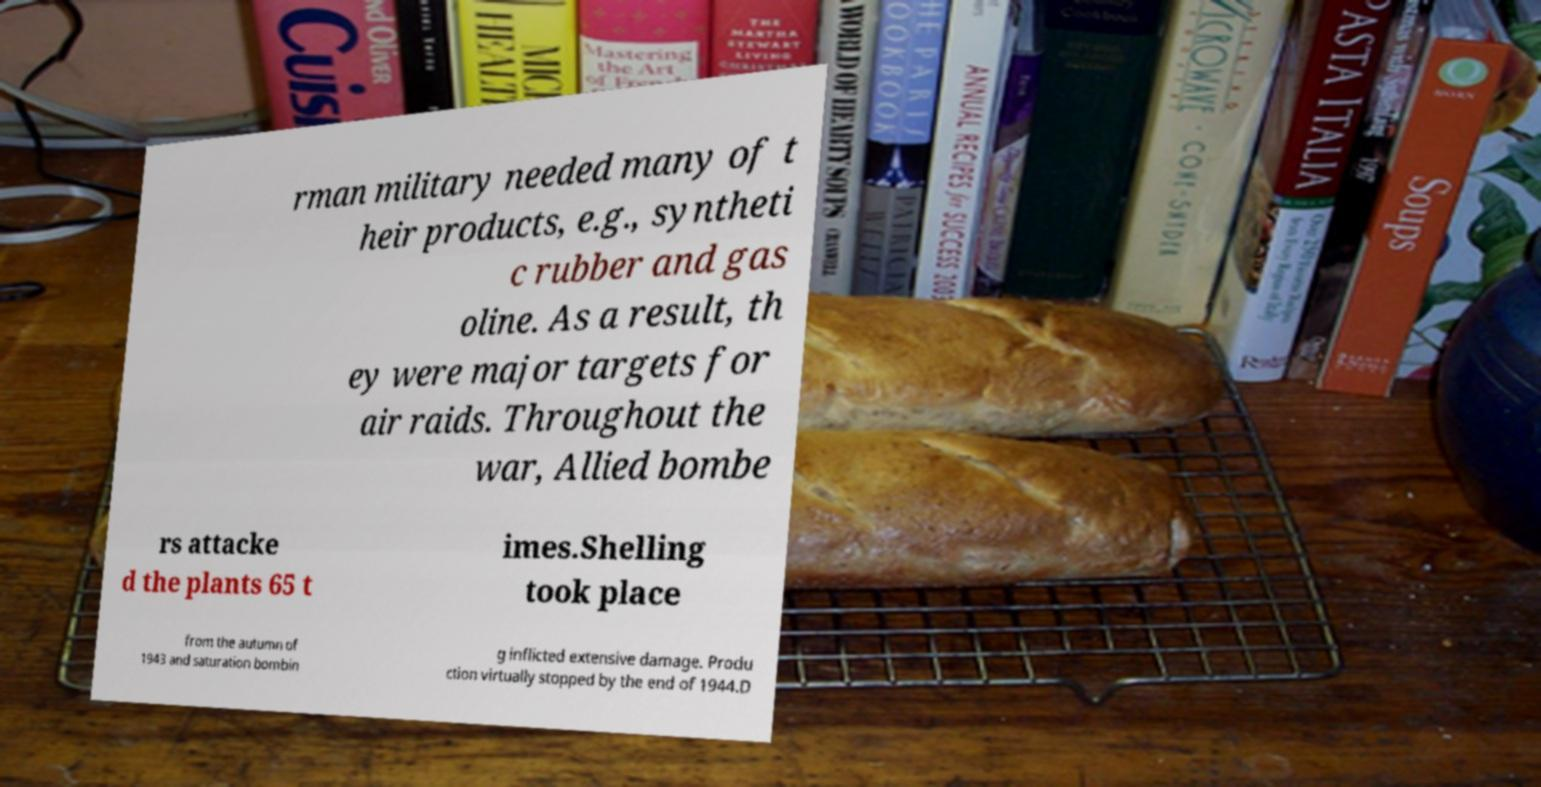Could you extract and type out the text from this image? rman military needed many of t heir products, e.g., syntheti c rubber and gas oline. As a result, th ey were major targets for air raids. Throughout the war, Allied bombe rs attacke d the plants 65 t imes.Shelling took place from the autumn of 1943 and saturation bombin g inflicted extensive damage. Produ ction virtually stopped by the end of 1944.D 